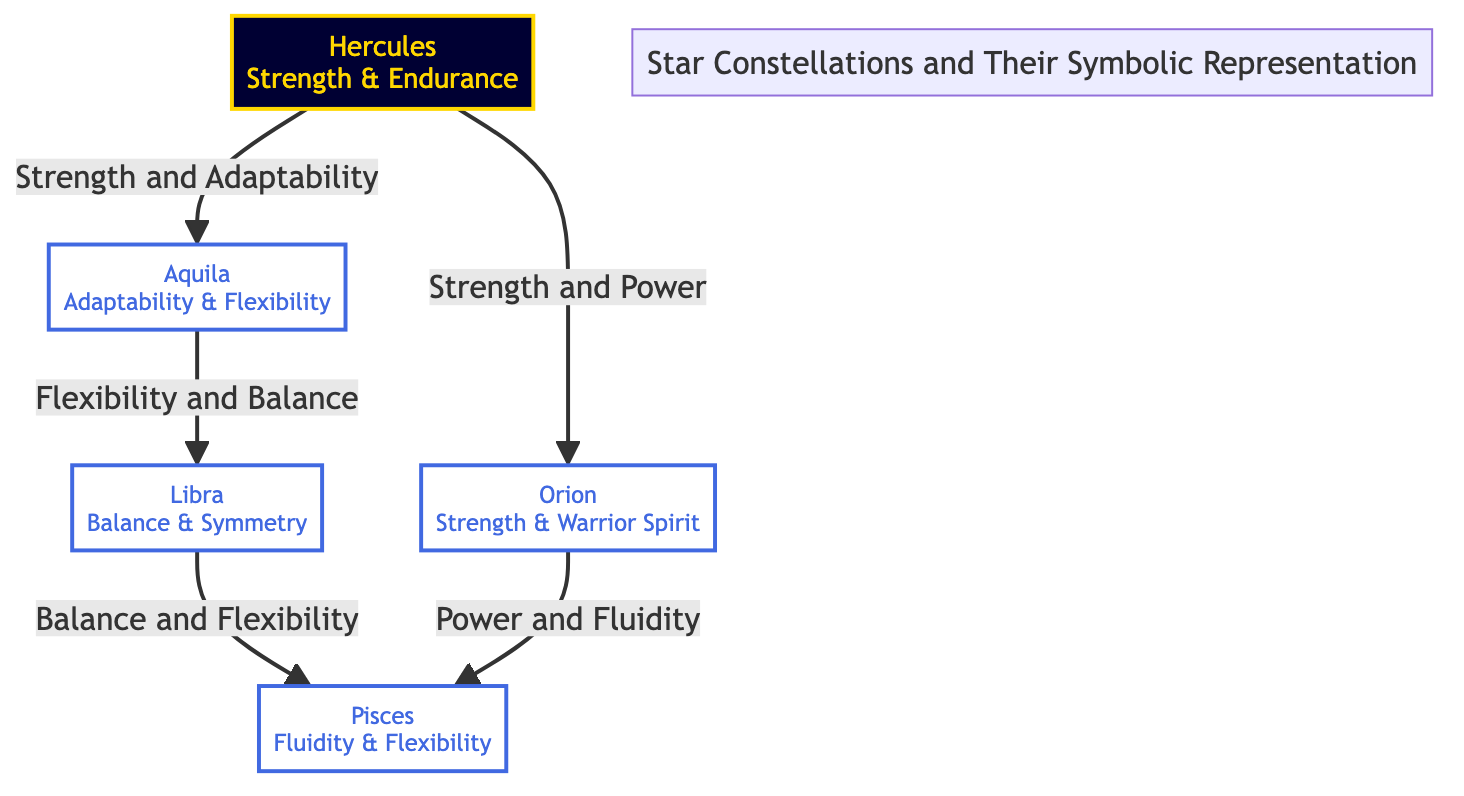What are the names of the constellations shown in the diagram? The diagram displays five constellations: Hercules, Orion, Aquila, Libra, and Pisces.
Answer: Hercules, Orion, Aquila, Libra, Pisces Which constellation symbolizes strength and endurance? According to the diagram, Hercules represents strength and endurance.
Answer: Hercules How many connections are there in total between the constellations? There are five connections indicated in the diagram between the constellations. Each connection represents a relationship.
Answer: 5 What is the relationship between Hercules and Aquila? The diagram shows that Hercules is connected to Aquila through the concept of "Strength and Adaptability".
Answer: Strength and Adaptability Which constellation is associated with balance and flexibility? Libra is the constellation that signifies balance and flexibility according to the diagram.
Answer: Libra Which two constellations are connected by the theme of flexibility? The constellations Aquila and Libra are connected, emphasizing flexibility and balance.
Answer: Aquila, Libra What does Pisces symbolize according to its connections in the diagram? Pisces embodies fluidity and flexibility, as indicated by its specific connections with other constellations.
Answer: Fluidity and Flexibility Who are the two constellations that share a connection with power? Orion and Pisces are connected through themes of power and fluidity, illustrating their shared significance.
Answer: Orion, Pisces What type of diagram is this, and what does it represent? This is an Astronomy Diagram that visually represents major star constellations and their symbolic meanings related to strength and flexibility.
Answer: Astronomy Diagram 